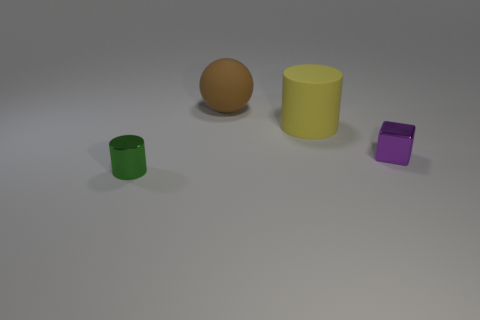There is a tiny metallic thing that is to the left of the big matte sphere; how many brown balls are in front of it?
Offer a very short reply. 0. Do the small green object and the big yellow thing have the same shape?
Your response must be concise. Yes. Are there any other things of the same color as the tiny block?
Make the answer very short. No. There is a tiny purple thing; is it the same shape as the tiny shiny thing that is to the left of the large yellow cylinder?
Provide a succinct answer. No. There is a small shiny object on the right side of the tiny metallic object that is on the left side of the big matte object behind the yellow cylinder; what color is it?
Make the answer very short. Purple. Are there any other things that have the same material as the green cylinder?
Make the answer very short. Yes. Do the tiny object left of the purple shiny object and the tiny purple shiny thing have the same shape?
Provide a short and direct response. No. What is the small green thing made of?
Offer a terse response. Metal. What is the shape of the tiny thing in front of the small shiny thing on the right side of the small metal thing in front of the tiny cube?
Provide a short and direct response. Cylinder. How many other objects are there of the same shape as the brown rubber object?
Ensure brevity in your answer.  0. 